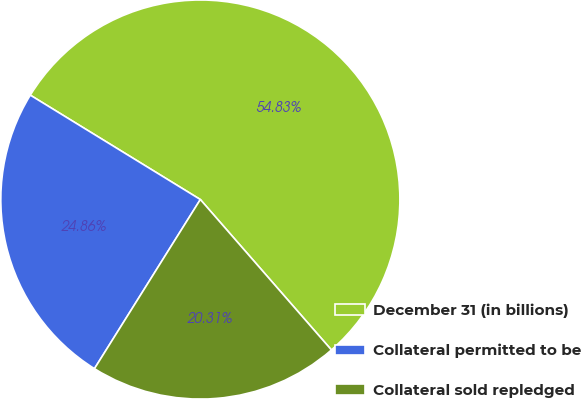Convert chart. <chart><loc_0><loc_0><loc_500><loc_500><pie_chart><fcel>December 31 (in billions)<fcel>Collateral permitted to be<fcel>Collateral sold repledged<nl><fcel>54.83%<fcel>24.86%<fcel>20.31%<nl></chart> 